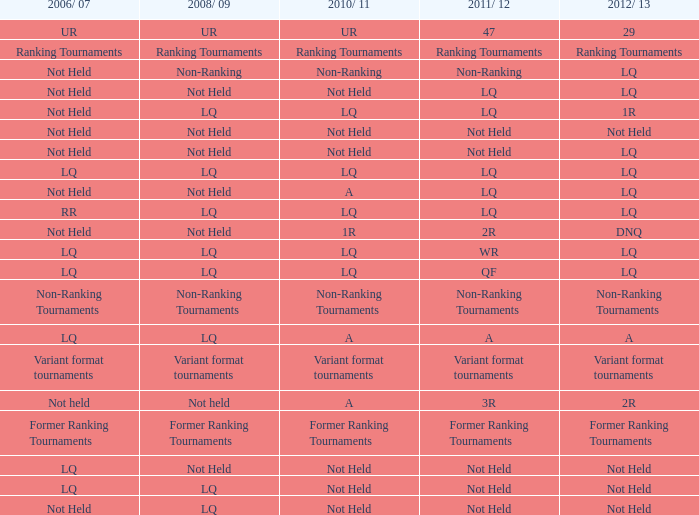What is 2008/09, when 2010/11 is UR? UR. 